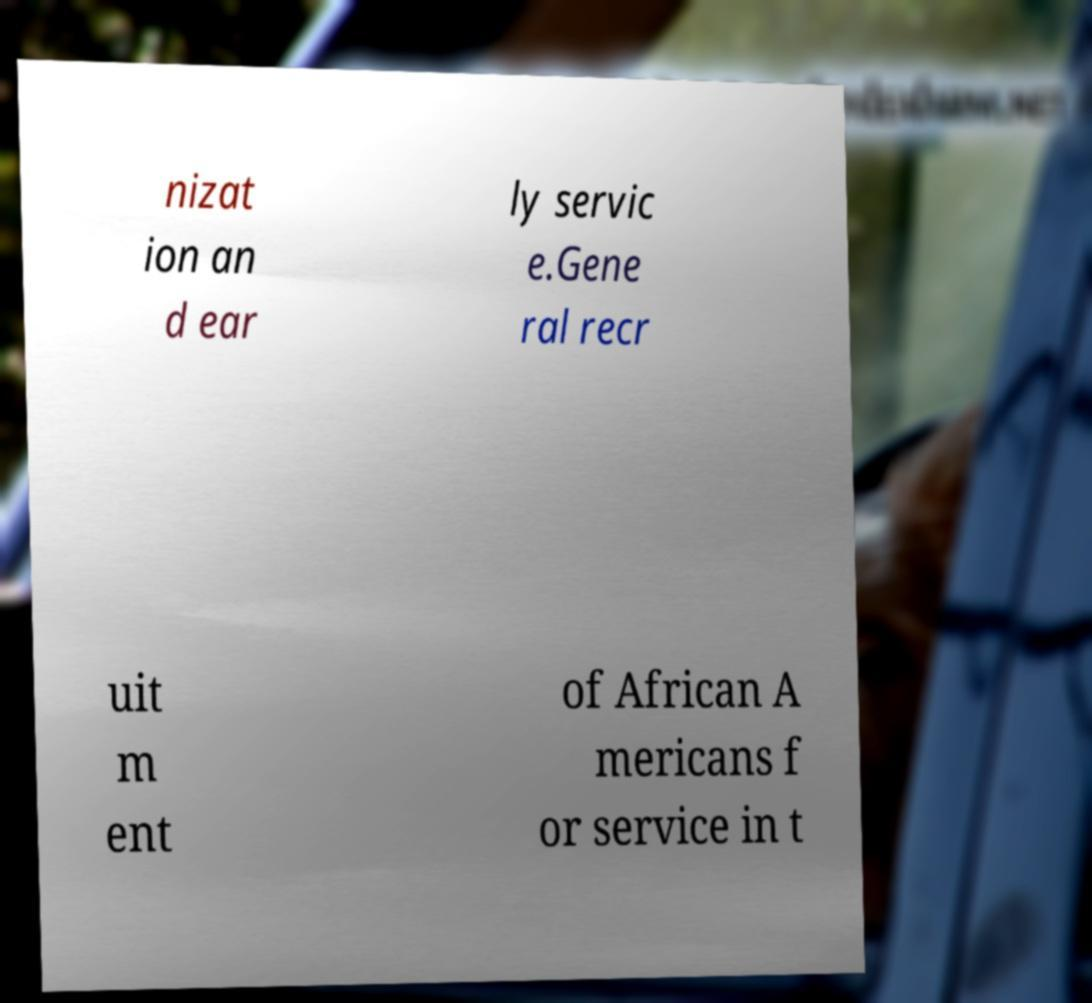I need the written content from this picture converted into text. Can you do that? nizat ion an d ear ly servic e.Gene ral recr uit m ent of African A mericans f or service in t 